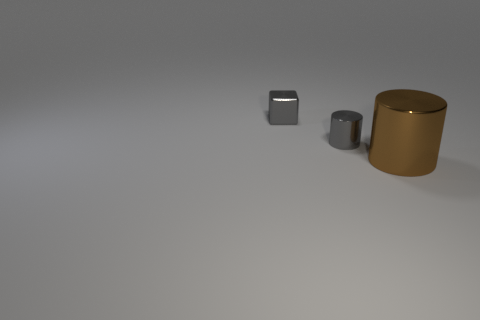There is a small cube that is the same color as the tiny shiny cylinder; what material is it?
Your answer should be very brief. Metal. How many objects are either small things behind the small gray metallic cylinder or big brown metal things that are in front of the metallic block?
Offer a terse response. 2. How many other objects are there of the same color as the block?
Offer a terse response. 1. There is a large brown metallic object; is its shape the same as the small gray object that is in front of the gray block?
Your answer should be very brief. Yes. Is the number of cubes on the left side of the cube less than the number of large things that are left of the small cylinder?
Provide a succinct answer. No. There is a small gray thing that is the same shape as the large brown metal thing; what material is it?
Provide a succinct answer. Metal. Is there any other thing that has the same material as the small gray cylinder?
Your response must be concise. Yes. Do the tiny metal cylinder and the small cube have the same color?
Provide a succinct answer. Yes. There is a gray object that is the same material as the gray cylinder; what is its shape?
Your answer should be compact. Cube. How many other large brown metallic objects are the same shape as the large object?
Ensure brevity in your answer.  0. 